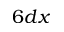Convert formula to latex. <formula><loc_0><loc_0><loc_500><loc_500>6 d x</formula> 